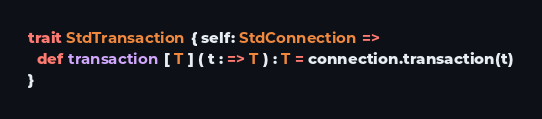<code> <loc_0><loc_0><loc_500><loc_500><_Scala_>trait StdTransaction { self: StdConnection =>
  def transaction [ T ] ( t : => T ) : T = connection.transaction(t)
}
</code> 